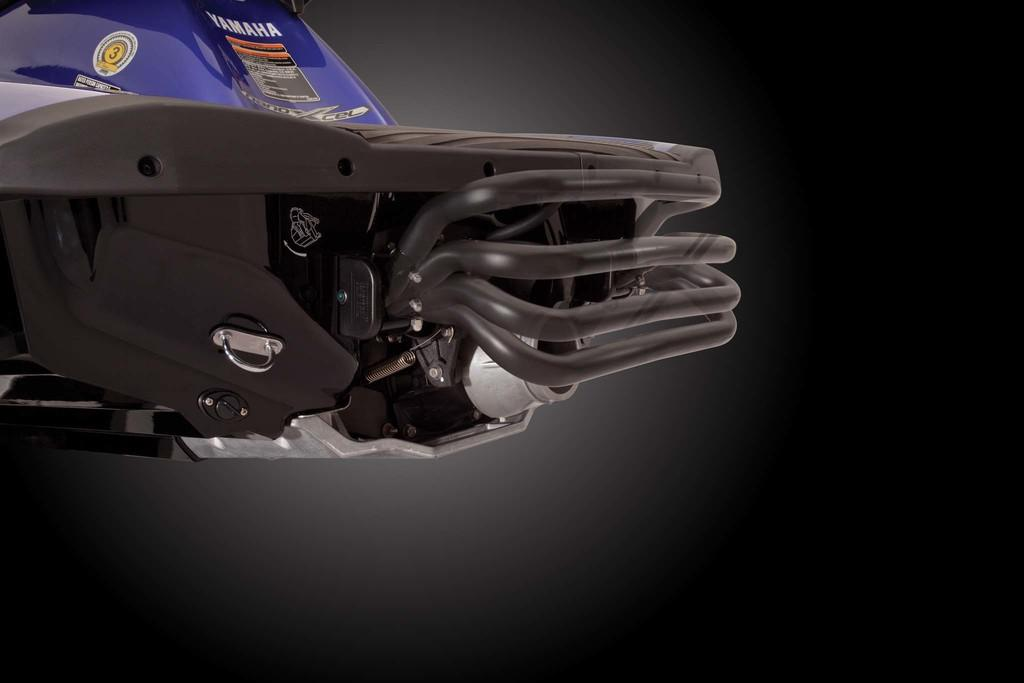What is the main subject of the image? There is a vehicle in the image. Can you describe the background of the image? The background of the image is dark. What type of stem can be seen growing from the vehicle in the image? There is no stem growing from the vehicle in the image. What kind of quartz is visible on the hood of the vehicle in the image? There is no quartz present on the vehicle in the image. 